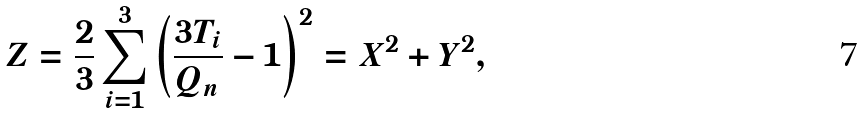<formula> <loc_0><loc_0><loc_500><loc_500>Z = \frac { 2 } { 3 } \sum ^ { 3 } _ { i = 1 } \left ( \frac { 3 T _ { i } } { Q _ { n } } - 1 \right ) ^ { 2 } = X ^ { 2 } + Y ^ { 2 } ,</formula> 